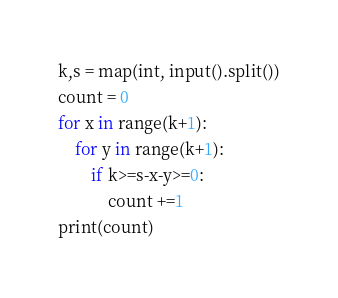Convert code to text. <code><loc_0><loc_0><loc_500><loc_500><_Python_>k,s = map(int, input().split())
count = 0
for x in range(k+1):
    for y in range(k+1):
        if k>=s-x-y>=0:
            count +=1
print(count)</code> 